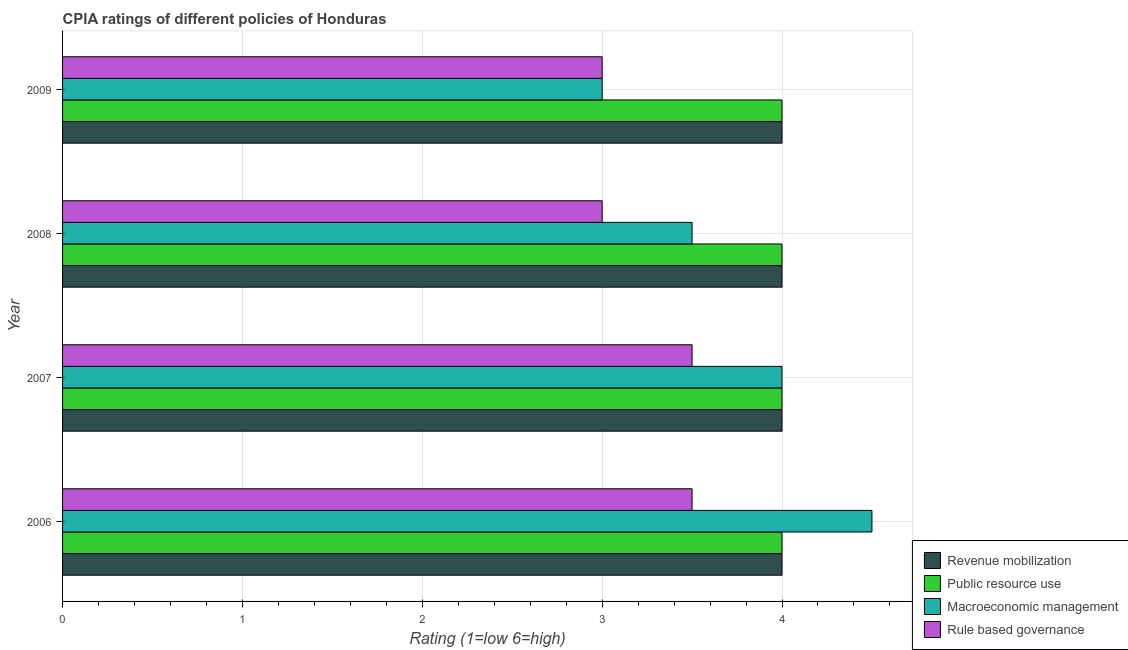How many groups of bars are there?
Offer a terse response. 4. Are the number of bars per tick equal to the number of legend labels?
Offer a terse response. Yes. Are the number of bars on each tick of the Y-axis equal?
Provide a short and direct response. Yes. What is the label of the 2nd group of bars from the top?
Offer a terse response. 2008. In how many cases, is the number of bars for a given year not equal to the number of legend labels?
Offer a very short reply. 0. What is the cpia rating of public resource use in 2006?
Offer a very short reply. 4. Across all years, what is the maximum cpia rating of public resource use?
Your answer should be very brief. 4. In which year was the cpia rating of public resource use maximum?
Your answer should be very brief. 2006. In which year was the cpia rating of macroeconomic management minimum?
Your response must be concise. 2009. What is the total cpia rating of revenue mobilization in the graph?
Provide a succinct answer. 16. What is the difference between the cpia rating of public resource use in 2006 and the cpia rating of rule based governance in 2008?
Offer a terse response. 1. In how many years, is the cpia rating of macroeconomic management greater than 1.4 ?
Provide a succinct answer. 4. What is the ratio of the cpia rating of rule based governance in 2006 to that in 2008?
Give a very brief answer. 1.17. Is the difference between the cpia rating of macroeconomic management in 2007 and 2009 greater than the difference between the cpia rating of public resource use in 2007 and 2009?
Your answer should be very brief. Yes. What is the difference between the highest and the second highest cpia rating of revenue mobilization?
Provide a succinct answer. 0. Is the sum of the cpia rating of rule based governance in 2008 and 2009 greater than the maximum cpia rating of public resource use across all years?
Your response must be concise. Yes. What does the 4th bar from the top in 2007 represents?
Offer a terse response. Revenue mobilization. What does the 1st bar from the bottom in 2007 represents?
Ensure brevity in your answer.  Revenue mobilization. Is it the case that in every year, the sum of the cpia rating of revenue mobilization and cpia rating of public resource use is greater than the cpia rating of macroeconomic management?
Your answer should be compact. Yes. How many bars are there?
Keep it short and to the point. 16. Are all the bars in the graph horizontal?
Offer a very short reply. Yes. What is the difference between two consecutive major ticks on the X-axis?
Offer a very short reply. 1. Are the values on the major ticks of X-axis written in scientific E-notation?
Keep it short and to the point. No. Does the graph contain any zero values?
Provide a succinct answer. No. Where does the legend appear in the graph?
Give a very brief answer. Bottom right. How are the legend labels stacked?
Your response must be concise. Vertical. What is the title of the graph?
Keep it short and to the point. CPIA ratings of different policies of Honduras. Does "Interest Payments" appear as one of the legend labels in the graph?
Keep it short and to the point. No. What is the label or title of the X-axis?
Give a very brief answer. Rating (1=low 6=high). What is the label or title of the Y-axis?
Ensure brevity in your answer.  Year. What is the Rating (1=low 6=high) in Revenue mobilization in 2006?
Ensure brevity in your answer.  4. What is the Rating (1=low 6=high) in Public resource use in 2006?
Make the answer very short. 4. What is the Rating (1=low 6=high) of Rule based governance in 2007?
Provide a succinct answer. 3.5. What is the Rating (1=low 6=high) in Revenue mobilization in 2008?
Make the answer very short. 4. What is the Rating (1=low 6=high) of Macroeconomic management in 2008?
Your answer should be compact. 3.5. What is the Rating (1=low 6=high) in Rule based governance in 2008?
Keep it short and to the point. 3. What is the Rating (1=low 6=high) of Public resource use in 2009?
Your answer should be very brief. 4. Across all years, what is the maximum Rating (1=low 6=high) in Revenue mobilization?
Give a very brief answer. 4. Across all years, what is the maximum Rating (1=low 6=high) of Macroeconomic management?
Give a very brief answer. 4.5. Across all years, what is the minimum Rating (1=low 6=high) in Public resource use?
Provide a short and direct response. 4. Across all years, what is the minimum Rating (1=low 6=high) of Rule based governance?
Provide a succinct answer. 3. What is the total Rating (1=low 6=high) of Revenue mobilization in the graph?
Make the answer very short. 16. What is the total Rating (1=low 6=high) in Rule based governance in the graph?
Provide a succinct answer. 13. What is the difference between the Rating (1=low 6=high) in Public resource use in 2006 and that in 2007?
Make the answer very short. 0. What is the difference between the Rating (1=low 6=high) of Public resource use in 2006 and that in 2008?
Keep it short and to the point. 0. What is the difference between the Rating (1=low 6=high) of Rule based governance in 2006 and that in 2008?
Give a very brief answer. 0.5. What is the difference between the Rating (1=low 6=high) of Revenue mobilization in 2006 and that in 2009?
Offer a terse response. 0. What is the difference between the Rating (1=low 6=high) in Revenue mobilization in 2007 and that in 2008?
Make the answer very short. 0. What is the difference between the Rating (1=low 6=high) in Public resource use in 2007 and that in 2008?
Offer a terse response. 0. What is the difference between the Rating (1=low 6=high) of Macroeconomic management in 2007 and that in 2008?
Your answer should be compact. 0.5. What is the difference between the Rating (1=low 6=high) in Rule based governance in 2007 and that in 2009?
Your response must be concise. 0.5. What is the difference between the Rating (1=low 6=high) in Revenue mobilization in 2008 and that in 2009?
Provide a short and direct response. 0. What is the difference between the Rating (1=low 6=high) of Public resource use in 2008 and that in 2009?
Keep it short and to the point. 0. What is the difference between the Rating (1=low 6=high) of Macroeconomic management in 2008 and that in 2009?
Provide a succinct answer. 0.5. What is the difference between the Rating (1=low 6=high) in Public resource use in 2006 and the Rating (1=low 6=high) in Rule based governance in 2007?
Your response must be concise. 0.5. What is the difference between the Rating (1=low 6=high) in Revenue mobilization in 2006 and the Rating (1=low 6=high) in Macroeconomic management in 2008?
Your answer should be very brief. 0.5. What is the difference between the Rating (1=low 6=high) of Public resource use in 2006 and the Rating (1=low 6=high) of Macroeconomic management in 2008?
Offer a terse response. 0.5. What is the difference between the Rating (1=low 6=high) in Revenue mobilization in 2006 and the Rating (1=low 6=high) in Public resource use in 2009?
Offer a terse response. 0. What is the difference between the Rating (1=low 6=high) of Public resource use in 2006 and the Rating (1=low 6=high) of Macroeconomic management in 2009?
Provide a succinct answer. 1. What is the difference between the Rating (1=low 6=high) of Macroeconomic management in 2006 and the Rating (1=low 6=high) of Rule based governance in 2009?
Give a very brief answer. 1.5. What is the difference between the Rating (1=low 6=high) in Revenue mobilization in 2007 and the Rating (1=low 6=high) in Macroeconomic management in 2008?
Make the answer very short. 0.5. What is the difference between the Rating (1=low 6=high) of Revenue mobilization in 2007 and the Rating (1=low 6=high) of Rule based governance in 2008?
Your answer should be very brief. 1. What is the difference between the Rating (1=low 6=high) in Public resource use in 2007 and the Rating (1=low 6=high) in Macroeconomic management in 2008?
Your response must be concise. 0.5. What is the difference between the Rating (1=low 6=high) in Revenue mobilization in 2007 and the Rating (1=low 6=high) in Public resource use in 2009?
Offer a very short reply. 0. What is the difference between the Rating (1=low 6=high) of Revenue mobilization in 2008 and the Rating (1=low 6=high) of Public resource use in 2009?
Your answer should be very brief. 0. What is the difference between the Rating (1=low 6=high) of Revenue mobilization in 2008 and the Rating (1=low 6=high) of Rule based governance in 2009?
Make the answer very short. 1. What is the difference between the Rating (1=low 6=high) in Public resource use in 2008 and the Rating (1=low 6=high) in Macroeconomic management in 2009?
Offer a very short reply. 1. What is the difference between the Rating (1=low 6=high) in Macroeconomic management in 2008 and the Rating (1=low 6=high) in Rule based governance in 2009?
Provide a short and direct response. 0.5. What is the average Rating (1=low 6=high) of Public resource use per year?
Keep it short and to the point. 4. What is the average Rating (1=low 6=high) of Macroeconomic management per year?
Provide a short and direct response. 3.75. In the year 2006, what is the difference between the Rating (1=low 6=high) in Revenue mobilization and Rating (1=low 6=high) in Macroeconomic management?
Provide a succinct answer. -0.5. In the year 2006, what is the difference between the Rating (1=low 6=high) of Revenue mobilization and Rating (1=low 6=high) of Rule based governance?
Make the answer very short. 0.5. In the year 2006, what is the difference between the Rating (1=low 6=high) in Public resource use and Rating (1=low 6=high) in Rule based governance?
Your answer should be very brief. 0.5. In the year 2007, what is the difference between the Rating (1=low 6=high) of Revenue mobilization and Rating (1=low 6=high) of Public resource use?
Provide a short and direct response. 0. In the year 2007, what is the difference between the Rating (1=low 6=high) of Revenue mobilization and Rating (1=low 6=high) of Macroeconomic management?
Offer a very short reply. 0. In the year 2007, what is the difference between the Rating (1=low 6=high) in Macroeconomic management and Rating (1=low 6=high) in Rule based governance?
Your answer should be very brief. 0.5. In the year 2008, what is the difference between the Rating (1=low 6=high) of Public resource use and Rating (1=low 6=high) of Macroeconomic management?
Offer a terse response. 0.5. In the year 2009, what is the difference between the Rating (1=low 6=high) in Revenue mobilization and Rating (1=low 6=high) in Macroeconomic management?
Ensure brevity in your answer.  1. In the year 2009, what is the difference between the Rating (1=low 6=high) of Public resource use and Rating (1=low 6=high) of Macroeconomic management?
Ensure brevity in your answer.  1. In the year 2009, what is the difference between the Rating (1=low 6=high) in Public resource use and Rating (1=low 6=high) in Rule based governance?
Offer a terse response. 1. In the year 2009, what is the difference between the Rating (1=low 6=high) in Macroeconomic management and Rating (1=low 6=high) in Rule based governance?
Provide a succinct answer. 0. What is the ratio of the Rating (1=low 6=high) in Public resource use in 2006 to that in 2007?
Provide a succinct answer. 1. What is the ratio of the Rating (1=low 6=high) of Revenue mobilization in 2006 to that in 2008?
Your response must be concise. 1. What is the ratio of the Rating (1=low 6=high) of Public resource use in 2006 to that in 2008?
Provide a succinct answer. 1. What is the ratio of the Rating (1=low 6=high) in Revenue mobilization in 2006 to that in 2009?
Give a very brief answer. 1. What is the ratio of the Rating (1=low 6=high) in Revenue mobilization in 2007 to that in 2008?
Provide a short and direct response. 1. What is the ratio of the Rating (1=low 6=high) of Public resource use in 2007 to that in 2009?
Your answer should be compact. 1. What is the ratio of the Rating (1=low 6=high) of Public resource use in 2008 to that in 2009?
Give a very brief answer. 1. What is the ratio of the Rating (1=low 6=high) of Macroeconomic management in 2008 to that in 2009?
Offer a terse response. 1.17. What is the difference between the highest and the second highest Rating (1=low 6=high) of Public resource use?
Provide a succinct answer. 0. What is the difference between the highest and the lowest Rating (1=low 6=high) of Revenue mobilization?
Make the answer very short. 0. What is the difference between the highest and the lowest Rating (1=low 6=high) in Public resource use?
Your answer should be very brief. 0. What is the difference between the highest and the lowest Rating (1=low 6=high) in Macroeconomic management?
Offer a very short reply. 1.5. What is the difference between the highest and the lowest Rating (1=low 6=high) of Rule based governance?
Provide a succinct answer. 0.5. 